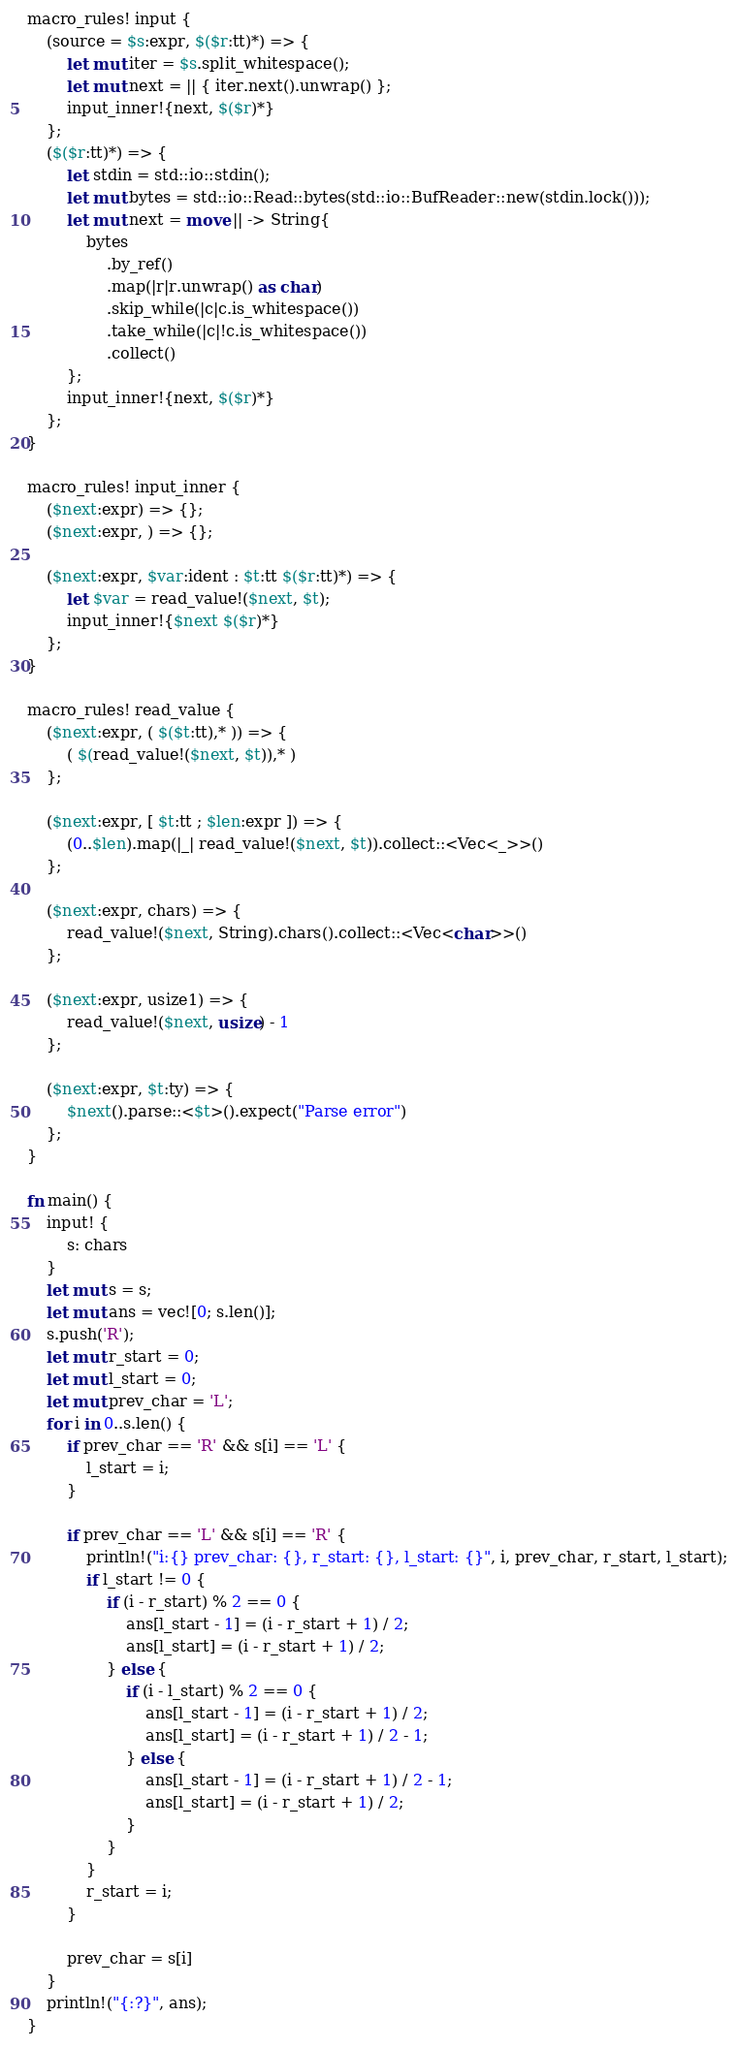<code> <loc_0><loc_0><loc_500><loc_500><_Rust_>macro_rules! input {
    (source = $s:expr, $($r:tt)*) => {
        let mut iter = $s.split_whitespace();
        let mut next = || { iter.next().unwrap() };
        input_inner!{next, $($r)*}
    };
    ($($r:tt)*) => {
        let stdin = std::io::stdin();
        let mut bytes = std::io::Read::bytes(std::io::BufReader::new(stdin.lock()));
        let mut next = move || -> String{
            bytes
                .by_ref()
                .map(|r|r.unwrap() as char)
                .skip_while(|c|c.is_whitespace())
                .take_while(|c|!c.is_whitespace())
                .collect()
        };
        input_inner!{next, $($r)*}
    };
}

macro_rules! input_inner {
    ($next:expr) => {};
    ($next:expr, ) => {};

    ($next:expr, $var:ident : $t:tt $($r:tt)*) => {
        let $var = read_value!($next, $t);
        input_inner!{$next $($r)*}
    };
}

macro_rules! read_value {
    ($next:expr, ( $($t:tt),* )) => {
        ( $(read_value!($next, $t)),* )
    };

    ($next:expr, [ $t:tt ; $len:expr ]) => {
        (0..$len).map(|_| read_value!($next, $t)).collect::<Vec<_>>()
    };

    ($next:expr, chars) => {
        read_value!($next, String).chars().collect::<Vec<char>>()
    };

    ($next:expr, usize1) => {
        read_value!($next, usize) - 1
    };

    ($next:expr, $t:ty) => {
        $next().parse::<$t>().expect("Parse error")
    };
}

fn main() {
    input! {
        s: chars
    }
    let mut s = s;
    let mut ans = vec![0; s.len()];
    s.push('R');
    let mut r_start = 0;
    let mut l_start = 0;
    let mut prev_char = 'L';
    for i in 0..s.len() {
        if prev_char == 'R' && s[i] == 'L' {
            l_start = i;
        }

        if prev_char == 'L' && s[i] == 'R' {
            println!("i:{} prev_char: {}, r_start: {}, l_start: {}", i, prev_char, r_start, l_start);
            if l_start != 0 {
                if (i - r_start) % 2 == 0 {
                    ans[l_start - 1] = (i - r_start + 1) / 2;
                    ans[l_start] = (i - r_start + 1) / 2;
                } else {
                    if (i - l_start) % 2 == 0 {
                        ans[l_start - 1] = (i - r_start + 1) / 2;
                        ans[l_start] = (i - r_start + 1) / 2 - 1;
                    } else {
                        ans[l_start - 1] = (i - r_start + 1) / 2 - 1;
                        ans[l_start] = (i - r_start + 1) / 2;
                    }
                }
            }
            r_start = i;
        }

        prev_char = s[i]
    }
    println!("{:?}", ans);
}
</code> 